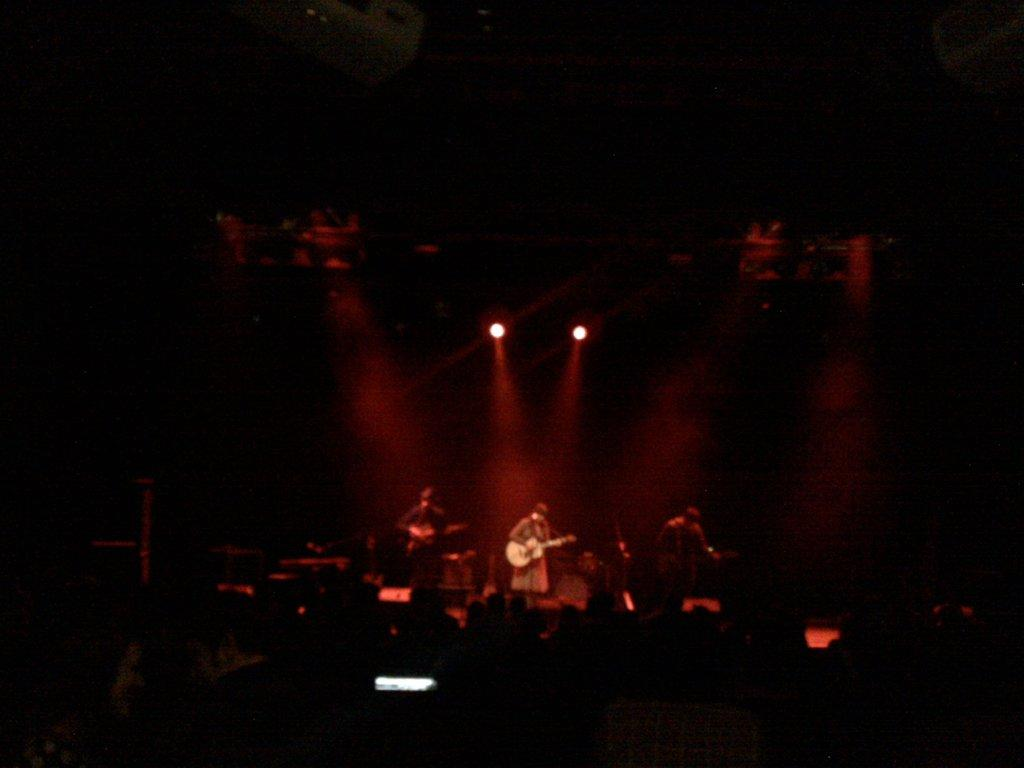Who or what is present in the image? There are people in the image. What are the people doing in the image? The people are playing guitar. Where are the people located in the image? The people are on a stage. What type of nut is being used to tune the guitar in the image? There is no nut visible in the image, and the guitar tuning process is not shown. 